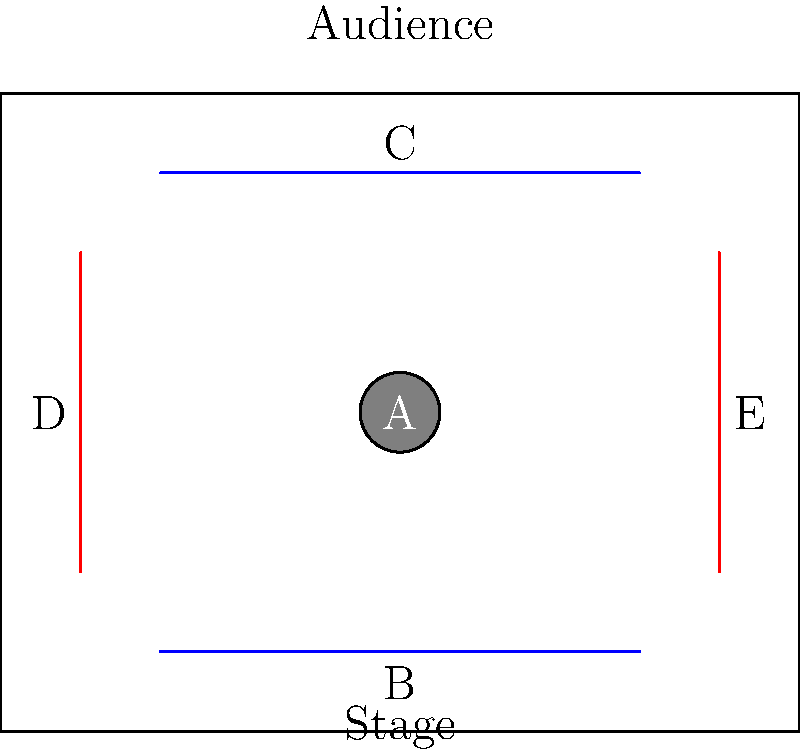In the given theatre stage layout diagram, which element represents the main performance area where actors are most likely to be positioned during key scenes? To answer this question, we need to analyze the stage layout diagram:

1. The diagram shows a rectangular stage with various elements labeled A through E.

2. Element A is represented by a circular shape in the center of the stage.

3. Elements B and C are horizontal lines at the front and back of the stage, respectively.

4. Elements D and E are vertical lines on the left and right sides of the stage.

5. In theatre design, the central area of the stage is typically the main performance space, as it offers the best visibility for the audience and allows for the most dynamic use of the stage.

6. The circular shape (A) in the center of the stage is likely representing this main performance area.

7. The other elements (B, C, D, and E) are probably representing curtains, backdrop, or wings, which are supporting elements of the stage rather than primary performance areas.

Therefore, element A, the circular shape in the center, is most likely to represent the main performance area where actors would be positioned during key scenes.
Answer: A 